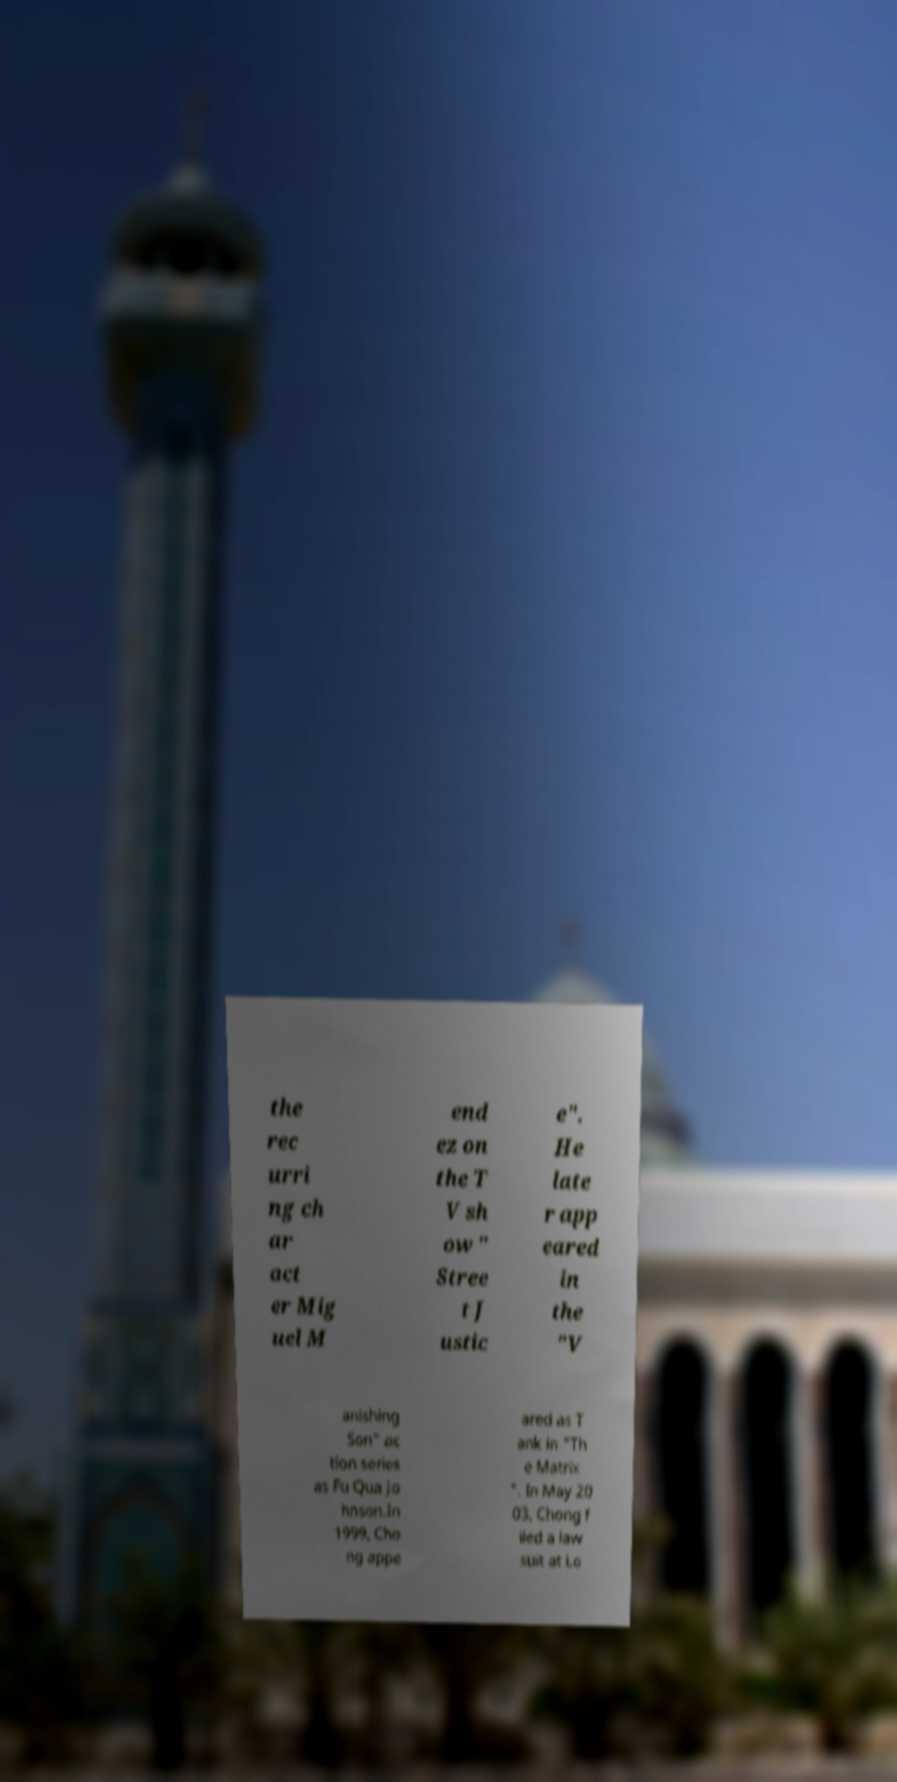I need the written content from this picture converted into text. Can you do that? the rec urri ng ch ar act er Mig uel M end ez on the T V sh ow " Stree t J ustic e". He late r app eared in the "V anishing Son" ac tion series as Fu Qua Jo hnson.In 1999, Cho ng appe ared as T ank in "Th e Matrix ". In May 20 03, Chong f iled a law suit at Lo 